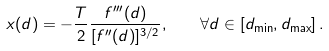Convert formula to latex. <formula><loc_0><loc_0><loc_500><loc_500>x ( d ) = - \frac { T } { 2 } \frac { f ^ { \prime \prime \prime } ( d ) } { [ f ^ { \prime \prime } ( d ) ] ^ { 3 / 2 } } , \quad \forall d \in [ d _ { \min } , d _ { \max } ] \, .</formula> 